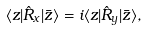<formula> <loc_0><loc_0><loc_500><loc_500>\langle z | \hat { R } _ { x } | \bar { z } \rangle = i \langle z | \hat { R } _ { y } | \bar { z } \rangle ,</formula> 